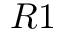<formula> <loc_0><loc_0><loc_500><loc_500>R 1</formula> 